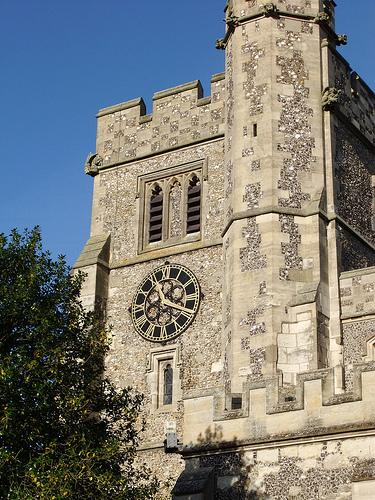Talk about the architectural styles and key features of the building in the image. The building is made of stone, with a clock tower, recessed arched windows, and a balcony featuring square shapes. Provide a concise description of the primary object in the image. A clock tower constructed of stone, featuring a black clock face with beige Roman numerals and hands. Mention the main subjects of the image and a secondary detail about them. The image features a clock tower made of stone, with a black clock face, and a tall green tree beside it. Evaluate the main architectural elements in the image. There is a stone building with a clock face, decorative windows, a balcony, and parapets on top. Explain how nature is interacting with the building in the image. A tall green tree stands beside the building and casts a shadow on the stone wall. Mention something animate and inanimate in the image. A green tree with leaves, beside a stone building with a clock face on it. Point out the primary color palette used in the image. The image consists mainly of beige from the stone building, green from the tree, and blue from the sky. Give a brief overview of the most prominent features in the image. A stone building with a clock tower, green tree, decorative windows, and a stone balcony. Describe the image by focusing on the two primary subjects. The image depicts a beige stone building, featuring a clock tower with Roman numerals on its face, alongside a tall green tree. Mention the main purpose of the building in the image and describe its appearance. The clock tower building constructed of stone serves as a time-telling monument with decorative windows, a balcony, and parapets. 